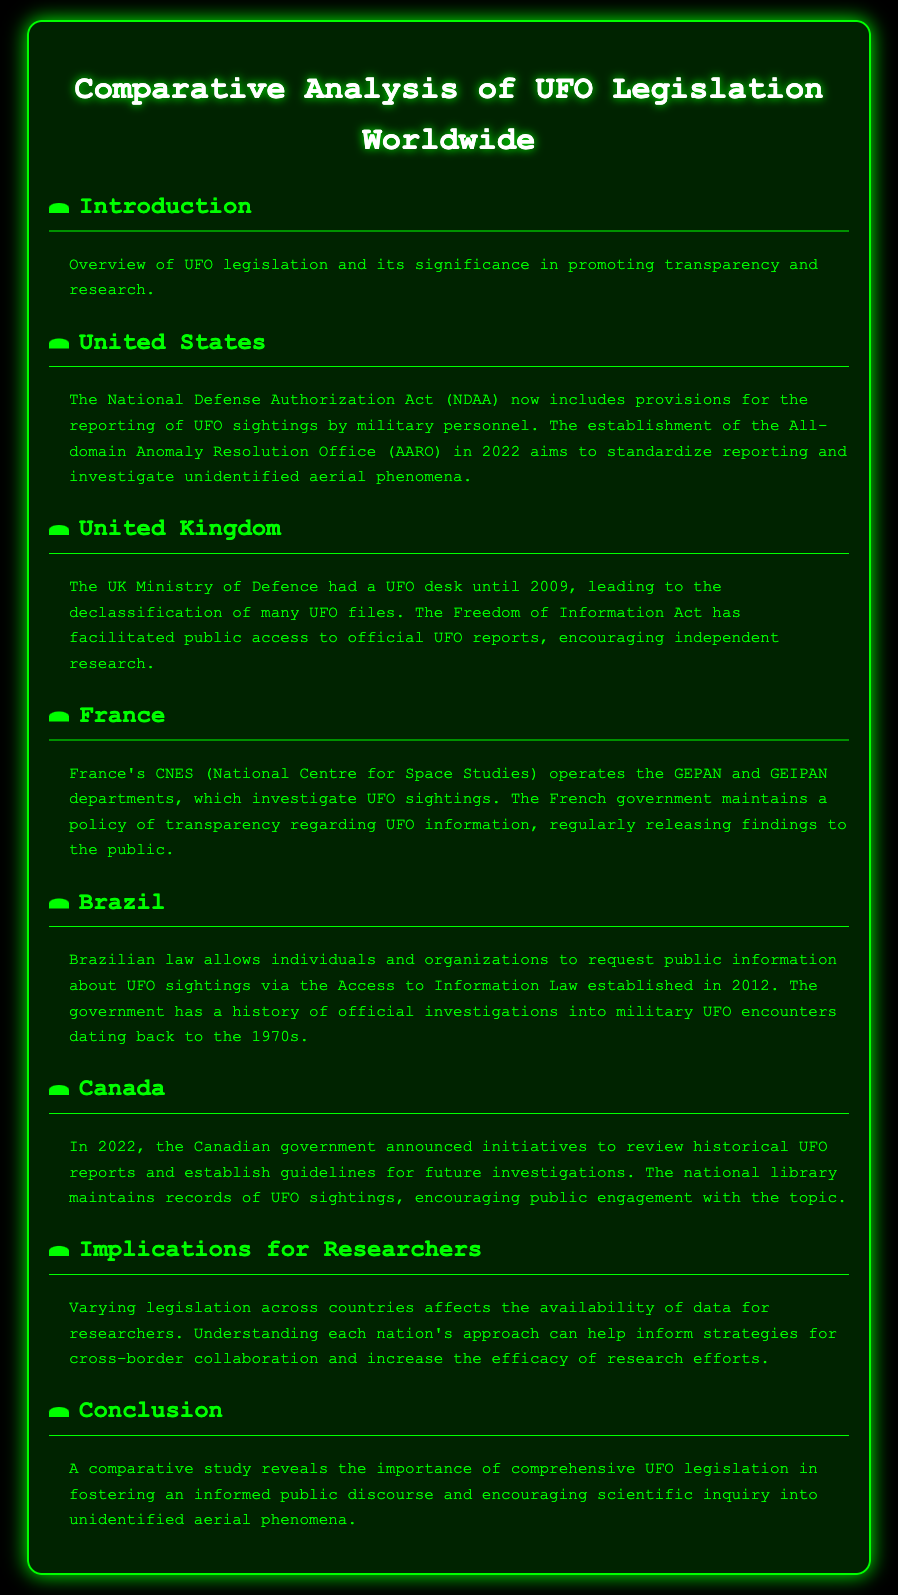What is the title of the document? The title of the document is provided in the header section, which is "Comparative Analysis of UFO Legislation Worldwide."
Answer: Comparative Analysis of UFO Legislation Worldwide What act includes provisions for reporting UFO sightings in the United States? The act mentioned is the "National Defense Authorization Act (NDAA)" which contains provisions for UFO sighting reporting.
Answer: National Defense Authorization Act (NDAA) Which department in France investigates UFO sightings? The department that investigates UFO sightings in France is mentioned as "GEPAN and GEIPAN" under the CNES (National Centre for Space Studies).
Answer: GEPAN and GEIPAN What year did Brazil establish the Access to Information Law? The Access to Information Law in Brazil was established in "2012."
Answer: 2012 What is the goal of the Canadian government's 2022 initiatives regarding UFOs? The goal of these initiatives is to review historical UFO reports and establish guidelines for future investigations.
Answer: Review historical UFO reports What does varying legislation across countries affect? The legislation affects "the availability of data for researchers," impacting research efforts.
Answer: Availability of data for researchers What does the conclusion emphasize about UFO legislation? The conclusion emphasizes the "importance of comprehensive UFO legislation" in fostering informed public discourse.
Answer: Importance of comprehensive UFO legislation What is one way the UK facilitated public access to UFO reports? The UK facilitated access through the "Freedom of Information Act."
Answer: Freedom of Information Act What is the primary focus of the document? The primary focus of the document is a "comparative analysis of UFO legislation worldwide."
Answer: Comparative analysis of UFO legislation worldwide 